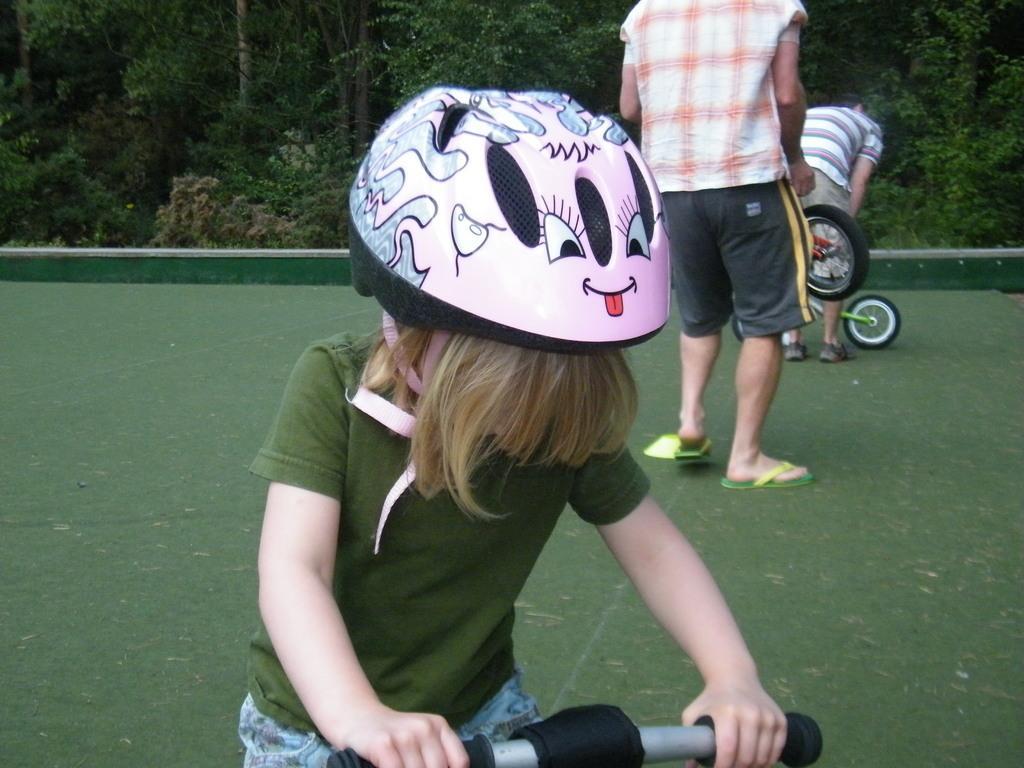Can you describe this image briefly? A child is holding a bicycle wearing a pink helmet, green t shirt and jeans. There are other people at the back. There are trees at the back. 